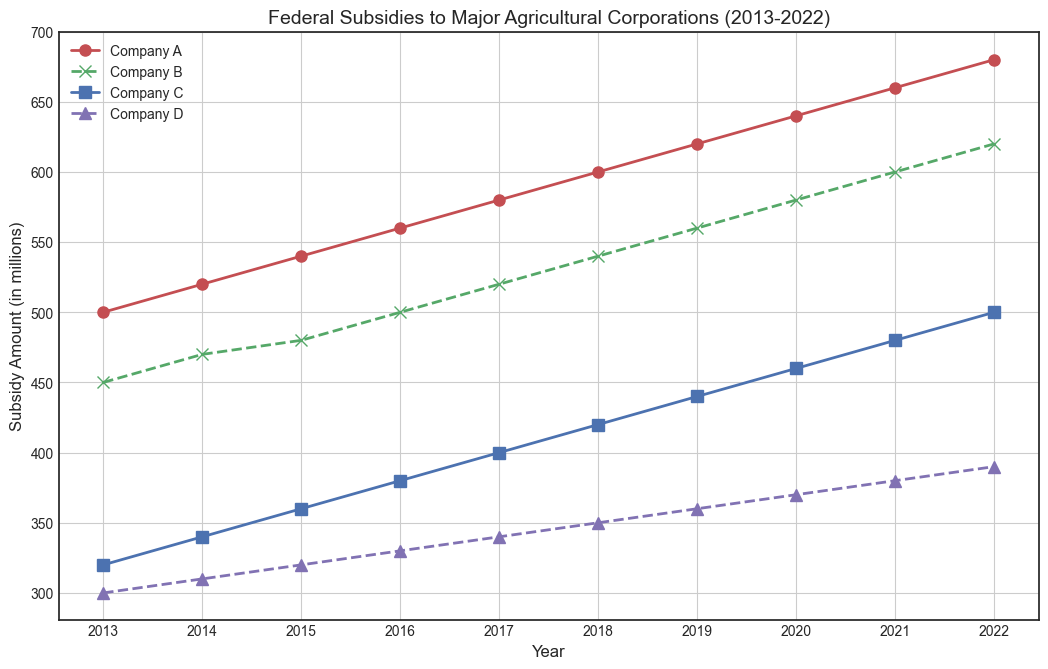What year did Company A receive the highest subsidy? The figure shows that Company A received increasing subsidies from 2013 to 2022. The highest subsidy for Company A is in 2022, as seen by the peak of the red line in that year.
Answer: 2022 How much more subsidy did Company A receive in 2022 compared to Company D? In 2022, Company A received 680 million, and Company D received 390 million. The difference is calculated as 680 - 390 = 290 million.
Answer: 290 million Which company showed the most consistent increase in subsidies over the years? All companies have upward trends, but Company A and Company B have the same consistent linear increase. By observing the slopes, Company A has a uniform and steeper increase.
Answer: Company A What is the total subsidy received by Company C over the decade? Summing up the annual subsidies for Company C from 2013 to 2022: 320 + 340 + 360 + 380 + 400 + 420 + 440 + 460 + 480 + 500 = 4100 million.
Answer: 4100 million Between which consecutive years did Company B see the largest increase in subsidies? Observing the green line for Company B, the year with the largest increase is between 2019 and 2020 where it increased from 560 million to 580 million which is a 20 million increase.
Answer: 2019 to 2020 What was the subsidy amount for Company D in 2015? The purple line (Company D) at 2015 shows the point marking the subsidy. It is at 320 million for that year.
Answer: 320 million How did the subsidy amount for Company C change from 2016 to 2017? From the figure, the subsidy for Company C in 2016 was 380 million, and in 2017 it was 400 million. The change is 400 - 380 = 20 million.
Answer: Increased by 20 million Which company had the smallest subsidy in 2013, and what was the amount? Observing the figure for 2013, Company D (purple line) had the smallest subsidy at 300 million.
Answer: Company D, 300 million What is the average annual subsidy received by Company B over the years? Adding the subsidies for Company B from 2013 to 2022: 450 + 470 + 480 + 500 + 520 + 540 + 560 + 580 + 600 + 620 = 5320 million. The average annual subsidy is 5320/10 = 532 million.
Answer: 532 million Compare the subsidy trends for Company A and Company C from 2015 to 2018. From 2015 to 2018, both companies show an increasing trend. Company A (red line) increases from 540 to 600 million, while Company C (blue line) increases from 360 to 420 million. Company A has a higher increase of 60 million compared to Company C's increase of 60 million.
Answer: Both have an increase, but Company A's increase is larger 